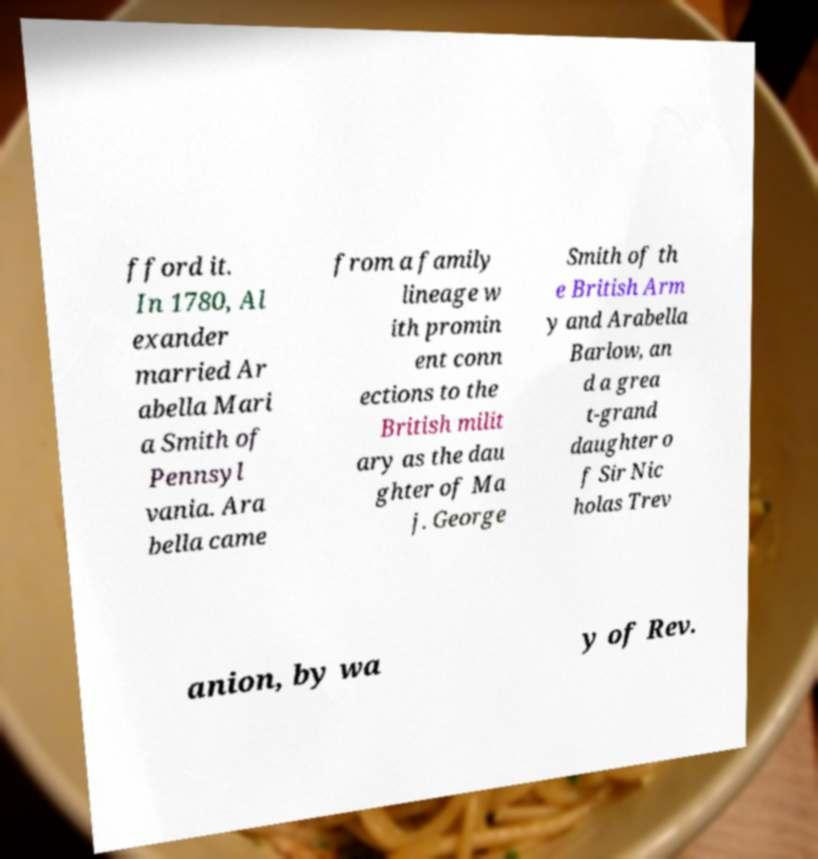For documentation purposes, I need the text within this image transcribed. Could you provide that? fford it. In 1780, Al exander married Ar abella Mari a Smith of Pennsyl vania. Ara bella came from a family lineage w ith promin ent conn ections to the British milit ary as the dau ghter of Ma j. George Smith of th e British Arm y and Arabella Barlow, an d a grea t-grand daughter o f Sir Nic holas Trev anion, by wa y of Rev. 